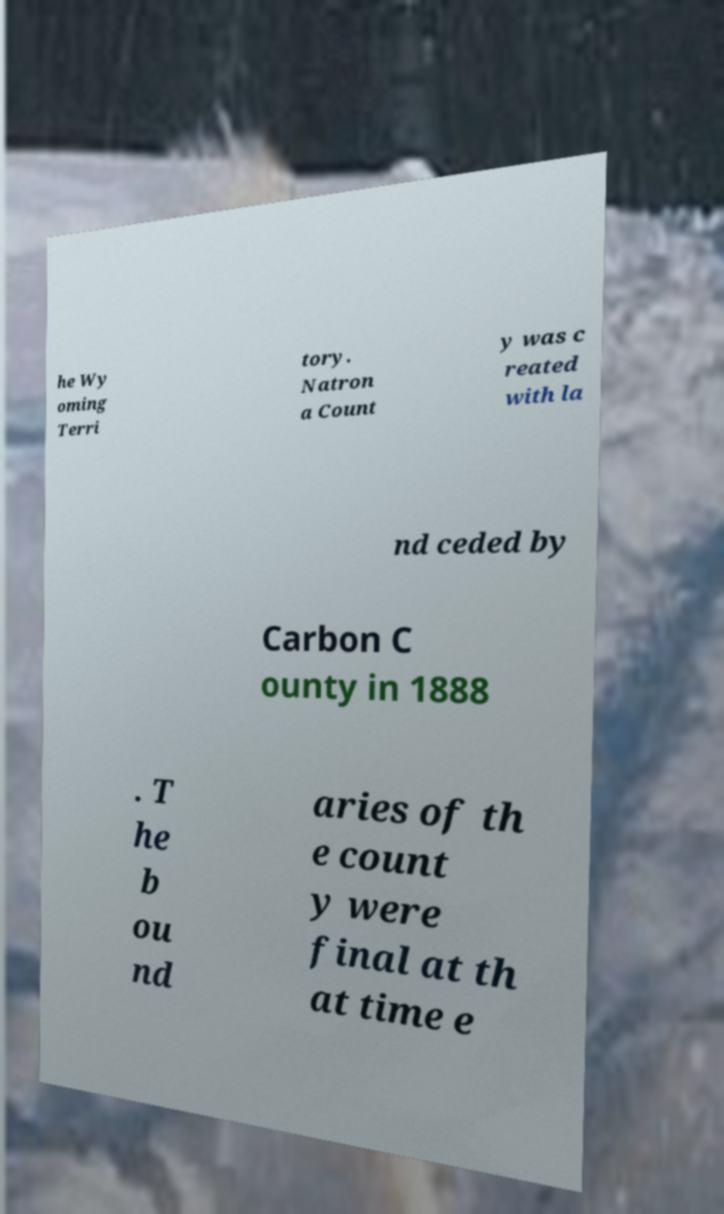Please read and relay the text visible in this image. What does it say? he Wy oming Terri tory. Natron a Count y was c reated with la nd ceded by Carbon C ounty in 1888 . T he b ou nd aries of th e count y were final at th at time e 